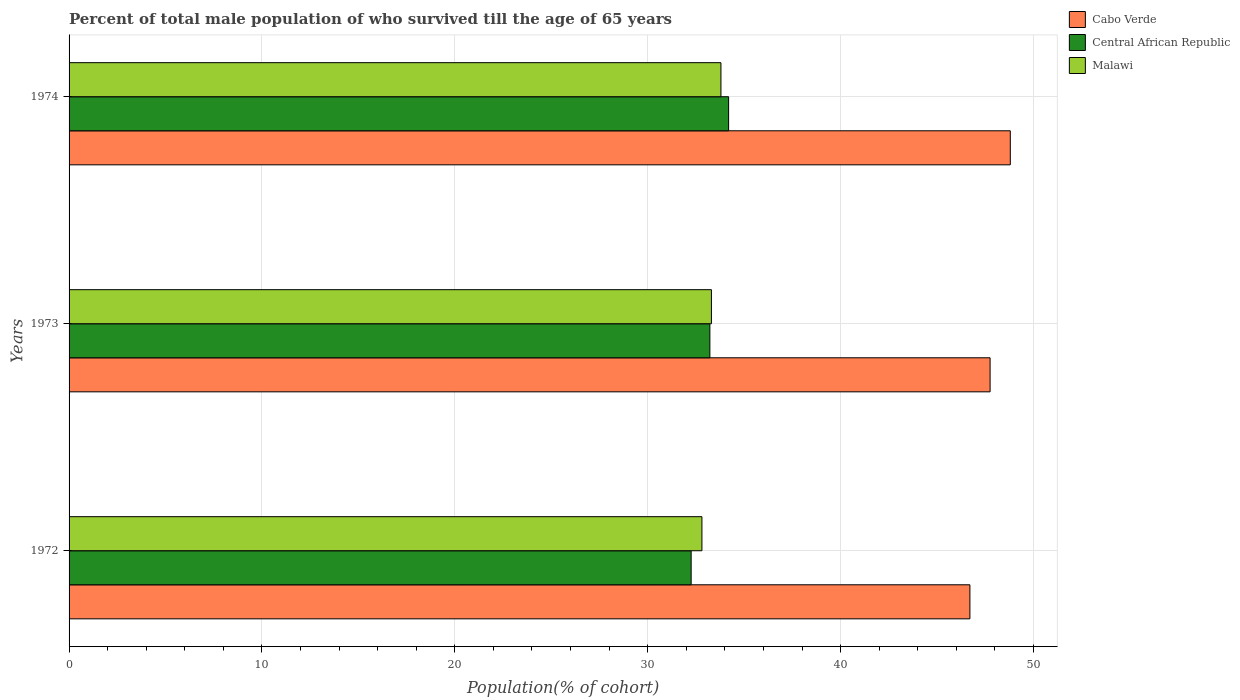Are the number of bars per tick equal to the number of legend labels?
Your answer should be compact. Yes. Are the number of bars on each tick of the Y-axis equal?
Give a very brief answer. Yes. What is the label of the 3rd group of bars from the top?
Your answer should be compact. 1972. In how many cases, is the number of bars for a given year not equal to the number of legend labels?
Keep it short and to the point. 0. What is the percentage of total male population who survived till the age of 65 years in Malawi in 1972?
Make the answer very short. 32.81. Across all years, what is the maximum percentage of total male population who survived till the age of 65 years in Malawi?
Your response must be concise. 33.8. Across all years, what is the minimum percentage of total male population who survived till the age of 65 years in Malawi?
Make the answer very short. 32.81. In which year was the percentage of total male population who survived till the age of 65 years in Central African Republic maximum?
Provide a short and direct response. 1974. In which year was the percentage of total male population who survived till the age of 65 years in Central African Republic minimum?
Make the answer very short. 1972. What is the total percentage of total male population who survived till the age of 65 years in Central African Republic in the graph?
Your answer should be compact. 99.67. What is the difference between the percentage of total male population who survived till the age of 65 years in Central African Republic in 1972 and that in 1974?
Provide a short and direct response. -1.94. What is the difference between the percentage of total male population who survived till the age of 65 years in Central African Republic in 1972 and the percentage of total male population who survived till the age of 65 years in Cabo Verde in 1974?
Provide a succinct answer. -16.55. What is the average percentage of total male population who survived till the age of 65 years in Malawi per year?
Make the answer very short. 33.3. In the year 1972, what is the difference between the percentage of total male population who survived till the age of 65 years in Cabo Verde and percentage of total male population who survived till the age of 65 years in Central African Republic?
Provide a succinct answer. 14.45. In how many years, is the percentage of total male population who survived till the age of 65 years in Cabo Verde greater than 48 %?
Ensure brevity in your answer.  1. What is the ratio of the percentage of total male population who survived till the age of 65 years in Cabo Verde in 1972 to that in 1973?
Your response must be concise. 0.98. Is the percentage of total male population who survived till the age of 65 years in Central African Republic in 1973 less than that in 1974?
Offer a terse response. Yes. What is the difference between the highest and the second highest percentage of total male population who survived till the age of 65 years in Central African Republic?
Your answer should be compact. 0.97. What is the difference between the highest and the lowest percentage of total male population who survived till the age of 65 years in Malawi?
Provide a succinct answer. 0.99. In how many years, is the percentage of total male population who survived till the age of 65 years in Cabo Verde greater than the average percentage of total male population who survived till the age of 65 years in Cabo Verde taken over all years?
Make the answer very short. 1. What does the 2nd bar from the top in 1972 represents?
Give a very brief answer. Central African Republic. What does the 2nd bar from the bottom in 1972 represents?
Provide a succinct answer. Central African Republic. Is it the case that in every year, the sum of the percentage of total male population who survived till the age of 65 years in Malawi and percentage of total male population who survived till the age of 65 years in Central African Republic is greater than the percentage of total male population who survived till the age of 65 years in Cabo Verde?
Ensure brevity in your answer.  Yes. What is the difference between two consecutive major ticks on the X-axis?
Your answer should be very brief. 10. Are the values on the major ticks of X-axis written in scientific E-notation?
Your response must be concise. No. Where does the legend appear in the graph?
Offer a very short reply. Top right. How many legend labels are there?
Provide a short and direct response. 3. How are the legend labels stacked?
Provide a short and direct response. Vertical. What is the title of the graph?
Provide a short and direct response. Percent of total male population of who survived till the age of 65 years. Does "St. Martin (French part)" appear as one of the legend labels in the graph?
Make the answer very short. No. What is the label or title of the X-axis?
Provide a succinct answer. Population(% of cohort). What is the Population(% of cohort) of Cabo Verde in 1972?
Ensure brevity in your answer.  46.71. What is the Population(% of cohort) of Central African Republic in 1972?
Your response must be concise. 32.25. What is the Population(% of cohort) in Malawi in 1972?
Provide a succinct answer. 32.81. What is the Population(% of cohort) in Cabo Verde in 1973?
Your answer should be very brief. 47.75. What is the Population(% of cohort) of Central African Republic in 1973?
Make the answer very short. 33.22. What is the Population(% of cohort) of Malawi in 1973?
Keep it short and to the point. 33.3. What is the Population(% of cohort) in Cabo Verde in 1974?
Keep it short and to the point. 48.8. What is the Population(% of cohort) of Central African Republic in 1974?
Provide a short and direct response. 34.2. What is the Population(% of cohort) of Malawi in 1974?
Keep it short and to the point. 33.8. Across all years, what is the maximum Population(% of cohort) in Cabo Verde?
Your answer should be very brief. 48.8. Across all years, what is the maximum Population(% of cohort) in Central African Republic?
Your answer should be compact. 34.2. Across all years, what is the maximum Population(% of cohort) in Malawi?
Offer a terse response. 33.8. Across all years, what is the minimum Population(% of cohort) of Cabo Verde?
Give a very brief answer. 46.71. Across all years, what is the minimum Population(% of cohort) of Central African Republic?
Make the answer very short. 32.25. Across all years, what is the minimum Population(% of cohort) of Malawi?
Offer a very short reply. 32.81. What is the total Population(% of cohort) of Cabo Verde in the graph?
Ensure brevity in your answer.  143.26. What is the total Population(% of cohort) in Central African Republic in the graph?
Ensure brevity in your answer.  99.67. What is the total Population(% of cohort) in Malawi in the graph?
Your answer should be compact. 99.91. What is the difference between the Population(% of cohort) in Cabo Verde in 1972 and that in 1973?
Your answer should be very brief. -1.05. What is the difference between the Population(% of cohort) of Central African Republic in 1972 and that in 1973?
Provide a short and direct response. -0.97. What is the difference between the Population(% of cohort) in Malawi in 1972 and that in 1973?
Give a very brief answer. -0.49. What is the difference between the Population(% of cohort) of Cabo Verde in 1972 and that in 1974?
Provide a short and direct response. -2.09. What is the difference between the Population(% of cohort) in Central African Republic in 1972 and that in 1974?
Your answer should be compact. -1.94. What is the difference between the Population(% of cohort) of Malawi in 1972 and that in 1974?
Your response must be concise. -0.99. What is the difference between the Population(% of cohort) of Cabo Verde in 1973 and that in 1974?
Offer a terse response. -1.05. What is the difference between the Population(% of cohort) of Central African Republic in 1973 and that in 1974?
Provide a short and direct response. -0.97. What is the difference between the Population(% of cohort) in Malawi in 1973 and that in 1974?
Offer a very short reply. -0.49. What is the difference between the Population(% of cohort) of Cabo Verde in 1972 and the Population(% of cohort) of Central African Republic in 1973?
Offer a very short reply. 13.48. What is the difference between the Population(% of cohort) of Cabo Verde in 1972 and the Population(% of cohort) of Malawi in 1973?
Keep it short and to the point. 13.4. What is the difference between the Population(% of cohort) of Central African Republic in 1972 and the Population(% of cohort) of Malawi in 1973?
Make the answer very short. -1.05. What is the difference between the Population(% of cohort) in Cabo Verde in 1972 and the Population(% of cohort) in Central African Republic in 1974?
Provide a succinct answer. 12.51. What is the difference between the Population(% of cohort) of Cabo Verde in 1972 and the Population(% of cohort) of Malawi in 1974?
Offer a terse response. 12.91. What is the difference between the Population(% of cohort) of Central African Republic in 1972 and the Population(% of cohort) of Malawi in 1974?
Your answer should be very brief. -1.54. What is the difference between the Population(% of cohort) of Cabo Verde in 1973 and the Population(% of cohort) of Central African Republic in 1974?
Keep it short and to the point. 13.56. What is the difference between the Population(% of cohort) in Cabo Verde in 1973 and the Population(% of cohort) in Malawi in 1974?
Give a very brief answer. 13.95. What is the difference between the Population(% of cohort) of Central African Republic in 1973 and the Population(% of cohort) of Malawi in 1974?
Provide a short and direct response. -0.57. What is the average Population(% of cohort) in Cabo Verde per year?
Your answer should be very brief. 47.75. What is the average Population(% of cohort) in Central African Republic per year?
Give a very brief answer. 33.22. What is the average Population(% of cohort) of Malawi per year?
Your answer should be very brief. 33.3. In the year 1972, what is the difference between the Population(% of cohort) of Cabo Verde and Population(% of cohort) of Central African Republic?
Your response must be concise. 14.45. In the year 1972, what is the difference between the Population(% of cohort) of Cabo Verde and Population(% of cohort) of Malawi?
Give a very brief answer. 13.89. In the year 1972, what is the difference between the Population(% of cohort) in Central African Republic and Population(% of cohort) in Malawi?
Provide a succinct answer. -0.56. In the year 1973, what is the difference between the Population(% of cohort) in Cabo Verde and Population(% of cohort) in Central African Republic?
Give a very brief answer. 14.53. In the year 1973, what is the difference between the Population(% of cohort) of Cabo Verde and Population(% of cohort) of Malawi?
Your answer should be compact. 14.45. In the year 1973, what is the difference between the Population(% of cohort) of Central African Republic and Population(% of cohort) of Malawi?
Keep it short and to the point. -0.08. In the year 1974, what is the difference between the Population(% of cohort) in Cabo Verde and Population(% of cohort) in Central African Republic?
Your answer should be compact. 14.6. In the year 1974, what is the difference between the Population(% of cohort) of Cabo Verde and Population(% of cohort) of Malawi?
Provide a short and direct response. 15. In the year 1974, what is the difference between the Population(% of cohort) of Central African Republic and Population(% of cohort) of Malawi?
Your response must be concise. 0.4. What is the ratio of the Population(% of cohort) of Cabo Verde in 1972 to that in 1973?
Your answer should be very brief. 0.98. What is the ratio of the Population(% of cohort) of Central African Republic in 1972 to that in 1973?
Provide a succinct answer. 0.97. What is the ratio of the Population(% of cohort) of Malawi in 1972 to that in 1973?
Offer a very short reply. 0.99. What is the ratio of the Population(% of cohort) in Cabo Verde in 1972 to that in 1974?
Your answer should be compact. 0.96. What is the ratio of the Population(% of cohort) of Central African Republic in 1972 to that in 1974?
Give a very brief answer. 0.94. What is the ratio of the Population(% of cohort) of Malawi in 1972 to that in 1974?
Make the answer very short. 0.97. What is the ratio of the Population(% of cohort) of Cabo Verde in 1973 to that in 1974?
Give a very brief answer. 0.98. What is the ratio of the Population(% of cohort) in Central African Republic in 1973 to that in 1974?
Offer a very short reply. 0.97. What is the ratio of the Population(% of cohort) in Malawi in 1973 to that in 1974?
Your response must be concise. 0.99. What is the difference between the highest and the second highest Population(% of cohort) of Cabo Verde?
Make the answer very short. 1.05. What is the difference between the highest and the second highest Population(% of cohort) of Central African Republic?
Make the answer very short. 0.97. What is the difference between the highest and the second highest Population(% of cohort) of Malawi?
Your answer should be very brief. 0.49. What is the difference between the highest and the lowest Population(% of cohort) of Cabo Verde?
Keep it short and to the point. 2.09. What is the difference between the highest and the lowest Population(% of cohort) in Central African Republic?
Give a very brief answer. 1.94. What is the difference between the highest and the lowest Population(% of cohort) of Malawi?
Give a very brief answer. 0.99. 